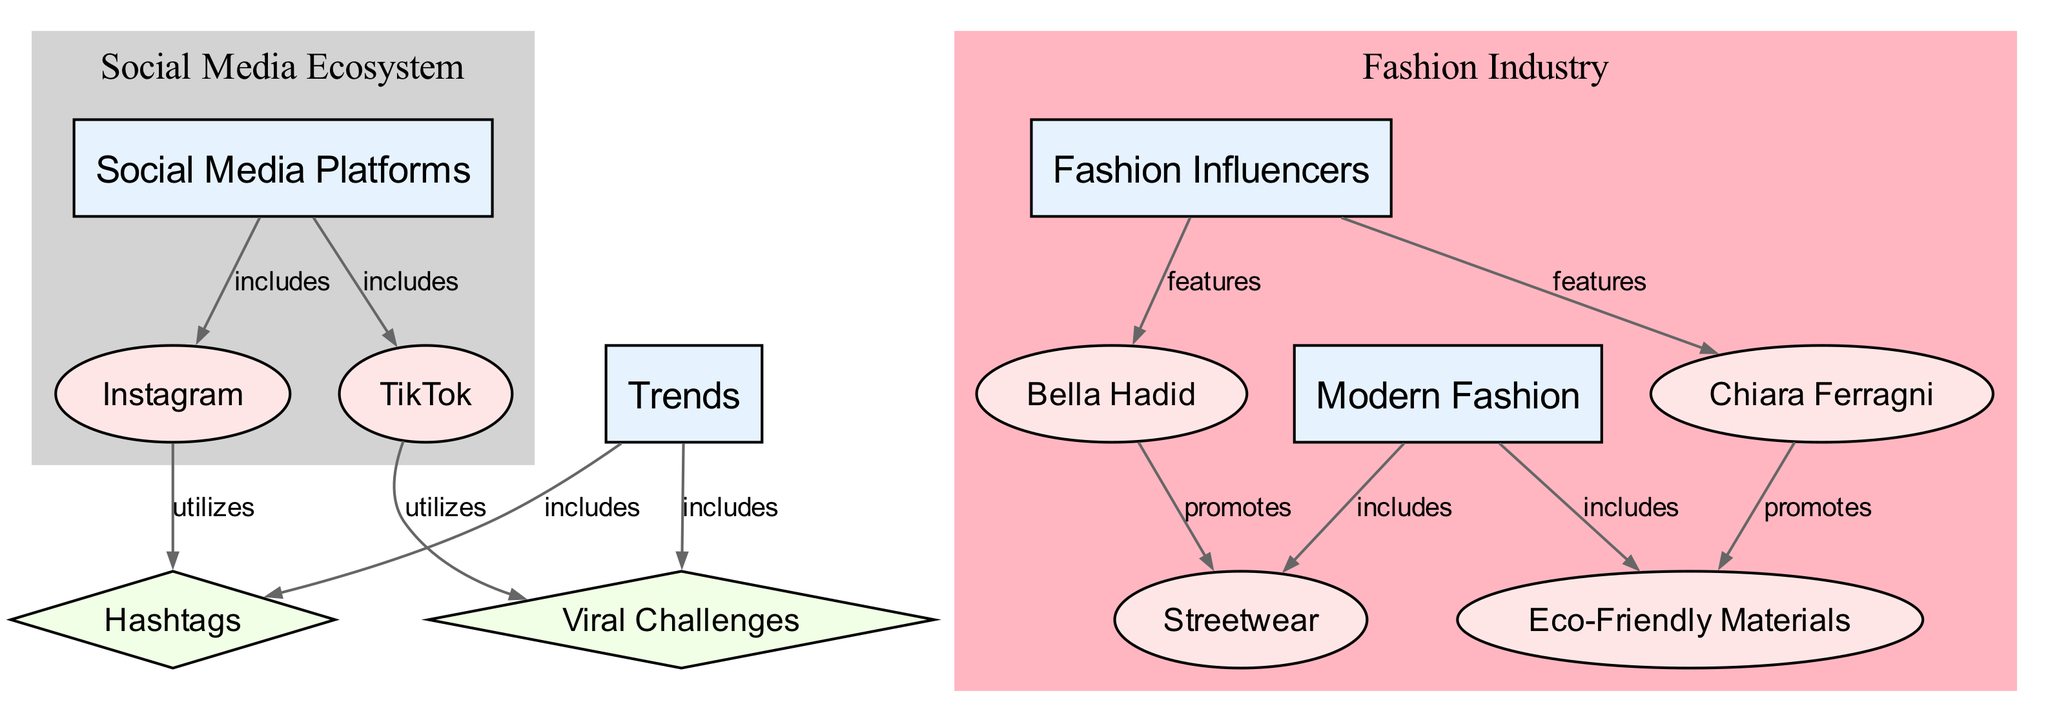What are the two social media platforms included in the diagram? The nodes "Instagram" and "TikTok" are directly connected to the node "Social Media Platforms" with an 'includes' relationship, indicating they are part of this category.
Answer: Instagram, TikTok How many mechanisms are associated with trends in the diagram? The nodes "Hashtags" and "Viral Challenges" are connected to the "Trends" node with an 'includes' relationship, which makes a total of two mechanisms related to trends.
Answer: 2 Who promotes Streetwear in the fashion industry? The node "Bella Hadid" is connected to "Streetwear" by a 'promotes' relationship, indicating that she is one of the promoters of this fashion style.
Answer: Bella Hadid What is the relationship type between Fashion Influencers and Instagram? The edge connecting "Fashion Influencers" to "Instagram" is labeled 'utilizes', indicating that Fashion Influencers use the platform Instagram to reach their audience.
Answer: utilizes Which modern fashion trend is promoted by Chiara Ferragni? The edge connects "Chiara Ferragni" to "Eco-Friendly Materials" with a 'promotes' relationship, showing that she advocates for eco-friendly fashion practices.
Answer: Eco-Friendly Materials What is the total number of entities present in the diagram? Counting the nodes labeled as 'entity', which include "Instagram", "TikTok", "Bella Hadid", "Chiara Ferragni", "Streetwear", and "Eco-Friendly Materials", results in a total of six entities.
Answer: 6 Which category does Streetwear belong to? The node "Streetwear" is connected to the "Modern Fashion" node with an 'includes' relationship, indicating that Streetwear is a part of the Modern Fashion category.
Answer: Modern Fashion What does TikTok utilize to create trends? The node "TikTok" is linked to "Viral Challenges" through a 'utilizes' relationship, indicating that the platform uses these challenges as a method to generate trends.
Answer: Viral Challenges What are the two categories represented in the diagram? The categories depicted in the diagram are "Social Media Platforms" and "Fashion Influencers". They encompass the various entities and mechanisms associated with the concepts presented.
Answer: Social Media Platforms, Fashion Influencers 